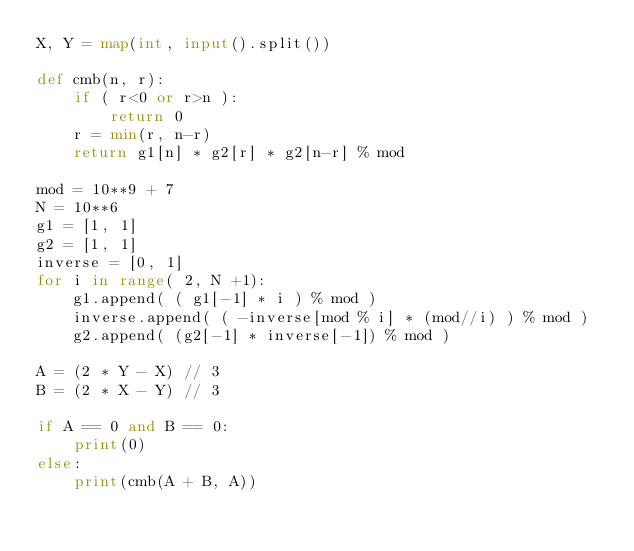<code> <loc_0><loc_0><loc_500><loc_500><_Python_>X, Y = map(int, input().split())

def cmb(n, r):
    if ( r<0 or r>n ):
        return 0
    r = min(r, n-r)
    return g1[n] * g2[r] * g2[n-r] % mod

mod = 10**9 + 7
N = 10**6
g1 = [1, 1]
g2 = [1, 1]
inverse = [0, 1]
for i in range( 2, N +1):
    g1.append( ( g1[-1] * i ) % mod )
    inverse.append( ( -inverse[mod % i] * (mod//i) ) % mod )
    g2.append( (g2[-1] * inverse[-1]) % mod )

A = (2 * Y - X) // 3
B = (2 * X - Y) // 3

if A == 0 and B == 0:
    print(0)
else:
    print(cmb(A + B, A))
</code> 